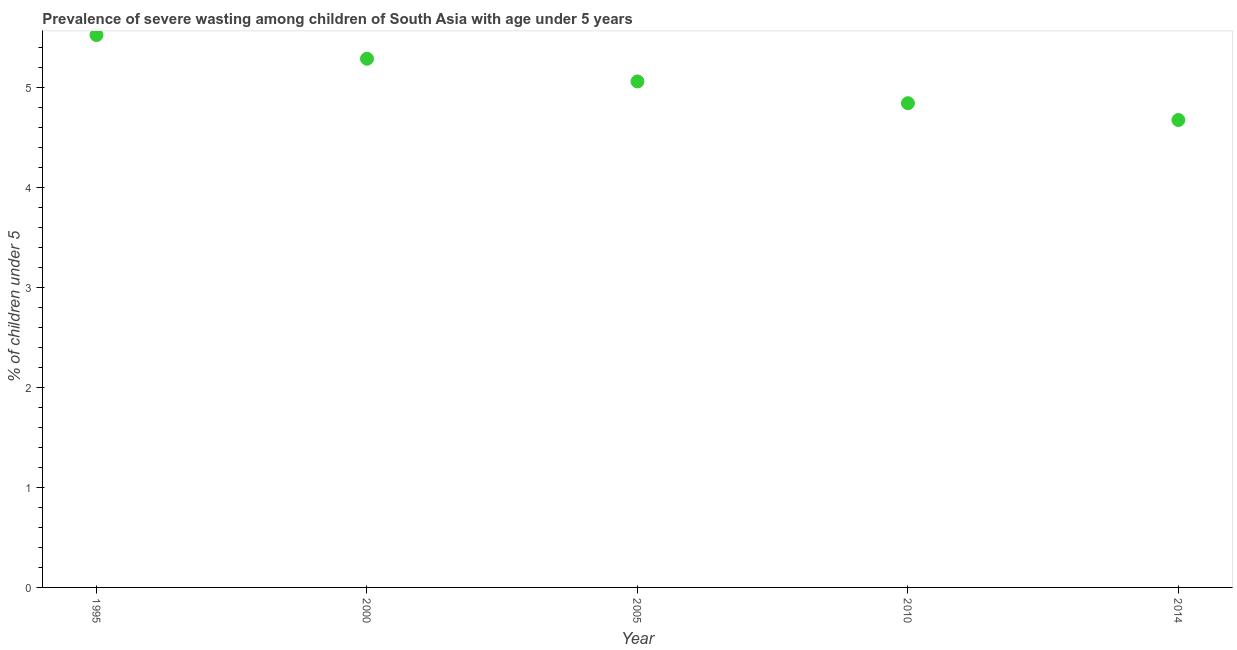What is the prevalence of severe wasting in 2005?
Provide a succinct answer. 5.06. Across all years, what is the maximum prevalence of severe wasting?
Provide a succinct answer. 5.52. Across all years, what is the minimum prevalence of severe wasting?
Offer a terse response. 4.67. In which year was the prevalence of severe wasting maximum?
Offer a terse response. 1995. In which year was the prevalence of severe wasting minimum?
Your answer should be very brief. 2014. What is the sum of the prevalence of severe wasting?
Your response must be concise. 25.37. What is the difference between the prevalence of severe wasting in 2005 and 2010?
Your response must be concise. 0.22. What is the average prevalence of severe wasting per year?
Your answer should be very brief. 5.07. What is the median prevalence of severe wasting?
Ensure brevity in your answer.  5.06. In how many years, is the prevalence of severe wasting greater than 4.2 %?
Provide a succinct answer. 5. Do a majority of the years between 2010 and 2014 (inclusive) have prevalence of severe wasting greater than 1.2 %?
Your answer should be compact. Yes. What is the ratio of the prevalence of severe wasting in 2005 to that in 2010?
Offer a terse response. 1.04. Is the prevalence of severe wasting in 1995 less than that in 2010?
Provide a short and direct response. No. Is the difference between the prevalence of severe wasting in 2000 and 2014 greater than the difference between any two years?
Keep it short and to the point. No. What is the difference between the highest and the second highest prevalence of severe wasting?
Your answer should be very brief. 0.24. Is the sum of the prevalence of severe wasting in 1995 and 2005 greater than the maximum prevalence of severe wasting across all years?
Ensure brevity in your answer.  Yes. What is the difference between the highest and the lowest prevalence of severe wasting?
Give a very brief answer. 0.85. In how many years, is the prevalence of severe wasting greater than the average prevalence of severe wasting taken over all years?
Make the answer very short. 2. How many dotlines are there?
Keep it short and to the point. 1. How many years are there in the graph?
Ensure brevity in your answer.  5. Are the values on the major ticks of Y-axis written in scientific E-notation?
Your answer should be very brief. No. Does the graph contain any zero values?
Give a very brief answer. No. What is the title of the graph?
Your answer should be very brief. Prevalence of severe wasting among children of South Asia with age under 5 years. What is the label or title of the Y-axis?
Your response must be concise.  % of children under 5. What is the  % of children under 5 in 1995?
Provide a succinct answer. 5.52. What is the  % of children under 5 in 2000?
Provide a succinct answer. 5.28. What is the  % of children under 5 in 2005?
Provide a short and direct response. 5.06. What is the  % of children under 5 in 2010?
Offer a very short reply. 4.84. What is the  % of children under 5 in 2014?
Your response must be concise. 4.67. What is the difference between the  % of children under 5 in 1995 and 2000?
Ensure brevity in your answer.  0.24. What is the difference between the  % of children under 5 in 1995 and 2005?
Offer a terse response. 0.46. What is the difference between the  % of children under 5 in 1995 and 2010?
Offer a very short reply. 0.68. What is the difference between the  % of children under 5 in 1995 and 2014?
Offer a very short reply. 0.85. What is the difference between the  % of children under 5 in 2000 and 2005?
Offer a very short reply. 0.23. What is the difference between the  % of children under 5 in 2000 and 2010?
Offer a very short reply. 0.44. What is the difference between the  % of children under 5 in 2000 and 2014?
Your answer should be compact. 0.61. What is the difference between the  % of children under 5 in 2005 and 2010?
Your answer should be compact. 0.22. What is the difference between the  % of children under 5 in 2005 and 2014?
Provide a short and direct response. 0.39. What is the difference between the  % of children under 5 in 2010 and 2014?
Make the answer very short. 0.17. What is the ratio of the  % of children under 5 in 1995 to that in 2000?
Give a very brief answer. 1.04. What is the ratio of the  % of children under 5 in 1995 to that in 2005?
Offer a terse response. 1.09. What is the ratio of the  % of children under 5 in 1995 to that in 2010?
Provide a succinct answer. 1.14. What is the ratio of the  % of children under 5 in 1995 to that in 2014?
Offer a terse response. 1.18. What is the ratio of the  % of children under 5 in 2000 to that in 2005?
Your answer should be compact. 1.04. What is the ratio of the  % of children under 5 in 2000 to that in 2010?
Your answer should be very brief. 1.09. What is the ratio of the  % of children under 5 in 2000 to that in 2014?
Your answer should be very brief. 1.13. What is the ratio of the  % of children under 5 in 2005 to that in 2010?
Keep it short and to the point. 1.04. What is the ratio of the  % of children under 5 in 2005 to that in 2014?
Ensure brevity in your answer.  1.08. What is the ratio of the  % of children under 5 in 2010 to that in 2014?
Ensure brevity in your answer.  1.04. 